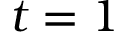Convert formula to latex. <formula><loc_0><loc_0><loc_500><loc_500>t = 1</formula> 